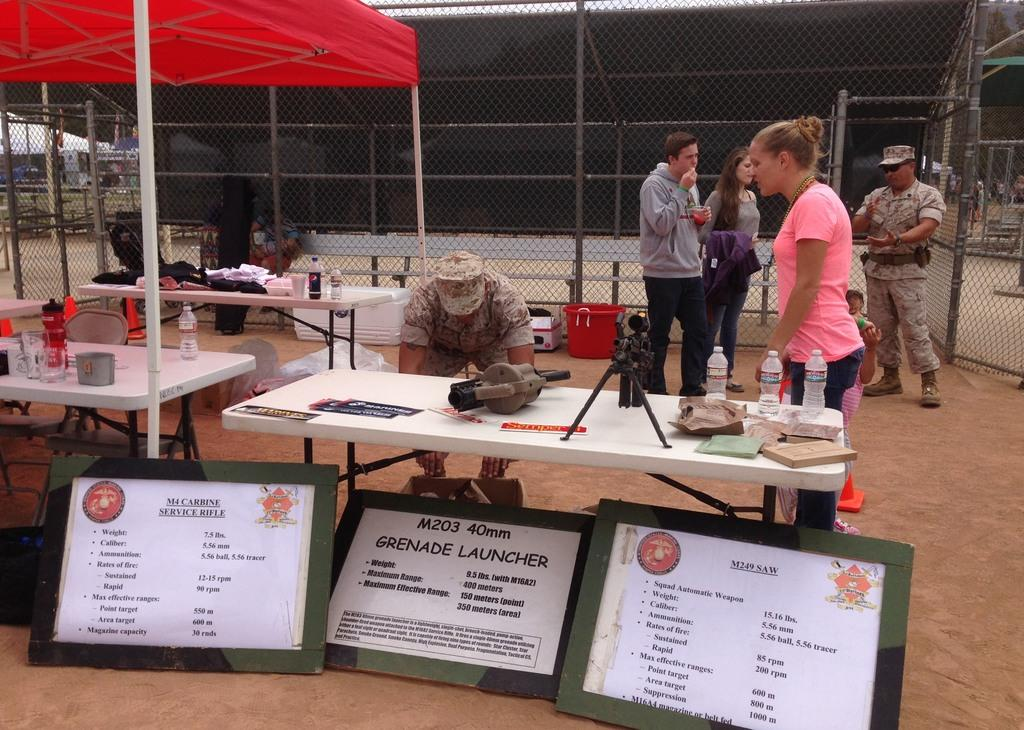What is the woman in the image doing? The woman is walking in the image. On which side of the image is the woman located? The woman is on the right side of the image. What items can be seen on the table in the image? There are water bottles on a table in the image. Where is the table located in the image? The table is on the left side of the image. What object is also present on the table with the water bottles? There is an umbrella on the table with the water bottles. What can be seen in the middle of the image? There are boards in the middle of the image. What type of vest is the snow wearing in the image? There is no snow or vest present in the image. 